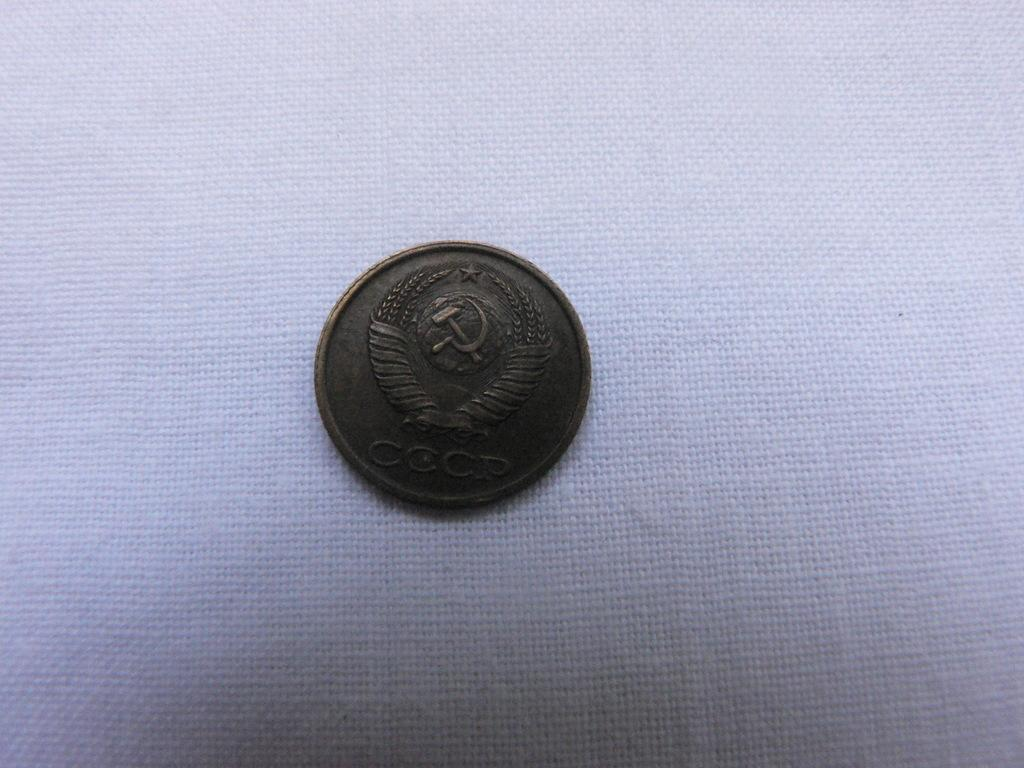Provide a one-sentence caption for the provided image. A coin that has a hammer and eagle on it. 